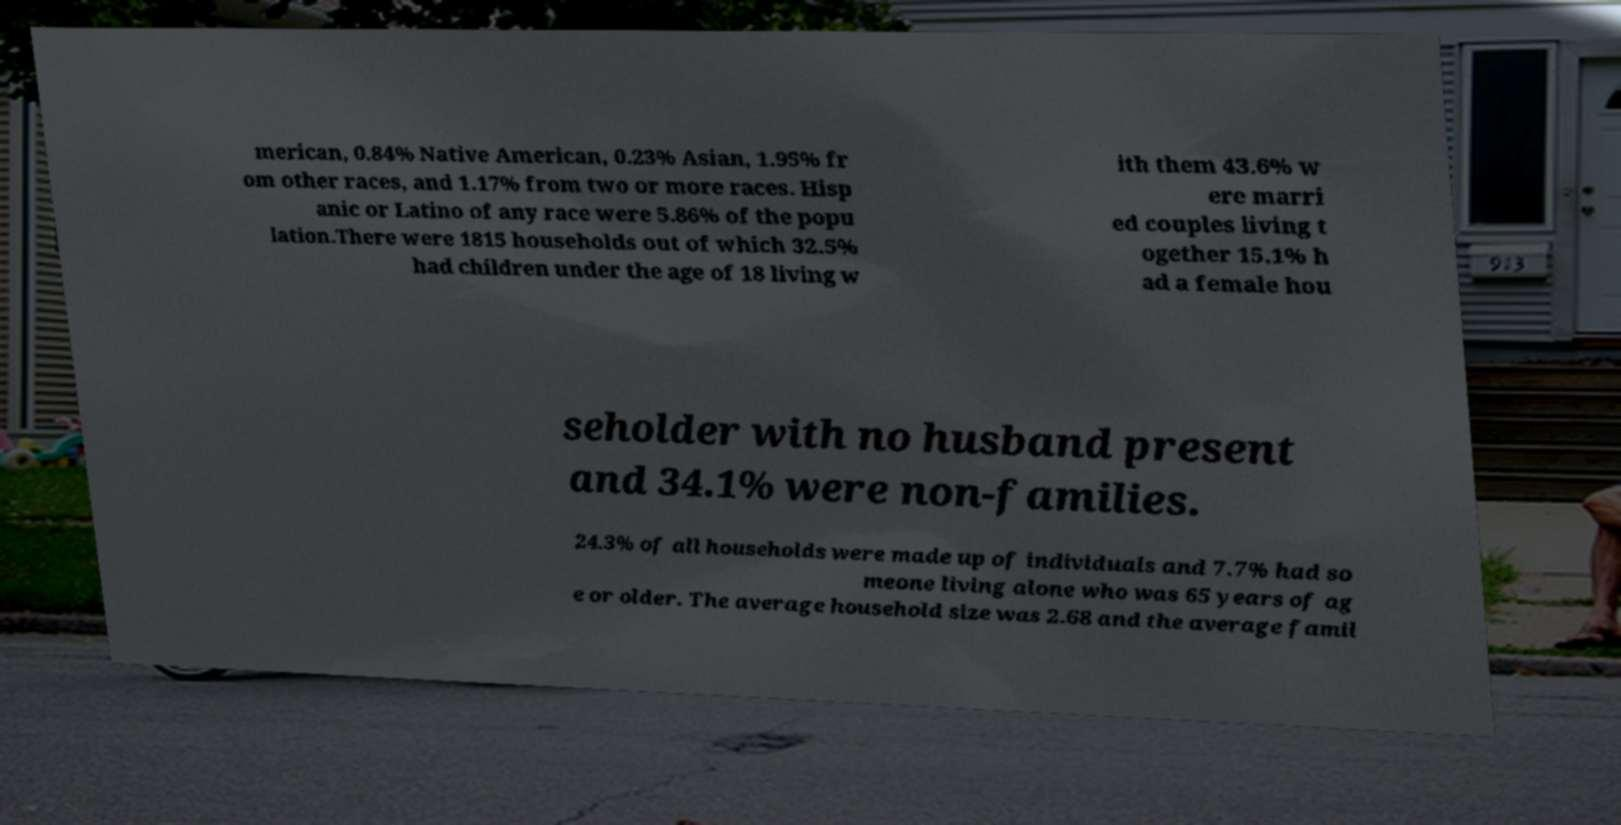For documentation purposes, I need the text within this image transcribed. Could you provide that? merican, 0.84% Native American, 0.23% Asian, 1.95% fr om other races, and 1.17% from two or more races. Hisp anic or Latino of any race were 5.86% of the popu lation.There were 1815 households out of which 32.5% had children under the age of 18 living w ith them 43.6% w ere marri ed couples living t ogether 15.1% h ad a female hou seholder with no husband present and 34.1% were non-families. 24.3% of all households were made up of individuals and 7.7% had so meone living alone who was 65 years of ag e or older. The average household size was 2.68 and the average famil 